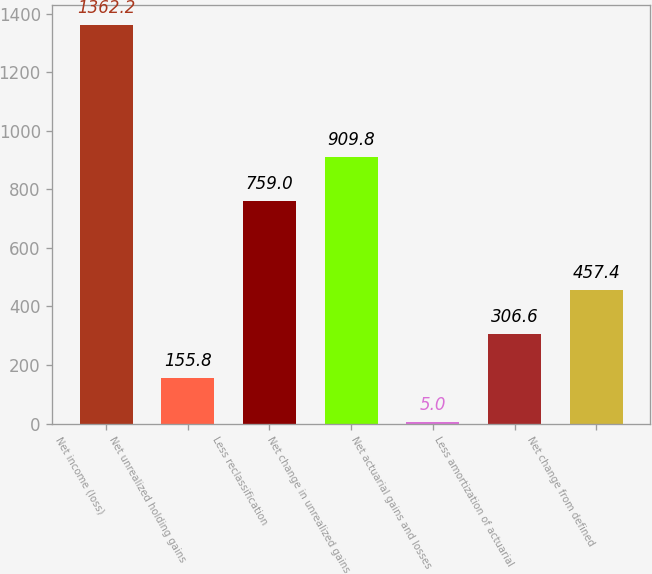Convert chart. <chart><loc_0><loc_0><loc_500><loc_500><bar_chart><fcel>Net income (loss)<fcel>Net unrealized holding gains<fcel>Less reclassification<fcel>Net change in unrealized gains<fcel>Net actuarial gains and losses<fcel>Less amortization of actuarial<fcel>Net change from defined<nl><fcel>1362.2<fcel>155.8<fcel>759<fcel>909.8<fcel>5<fcel>306.6<fcel>457.4<nl></chart> 